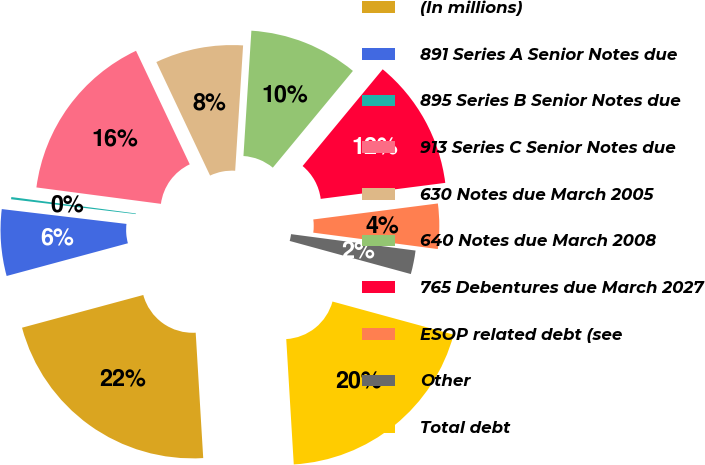Convert chart to OTSL. <chart><loc_0><loc_0><loc_500><loc_500><pie_chart><fcel>(In millions)<fcel>891 Series A Senior Notes due<fcel>895 Series B Senior Notes due<fcel>913 Series C Senior Notes due<fcel>630 Notes due March 2005<fcel>640 Notes due March 2008<fcel>765 Debentures due March 2027<fcel>ESOP related debt (see<fcel>Other<fcel>Total debt<nl><fcel>21.76%<fcel>6.08%<fcel>0.2%<fcel>15.88%<fcel>8.04%<fcel>10.0%<fcel>11.96%<fcel>4.12%<fcel>2.16%<fcel>19.8%<nl></chart> 